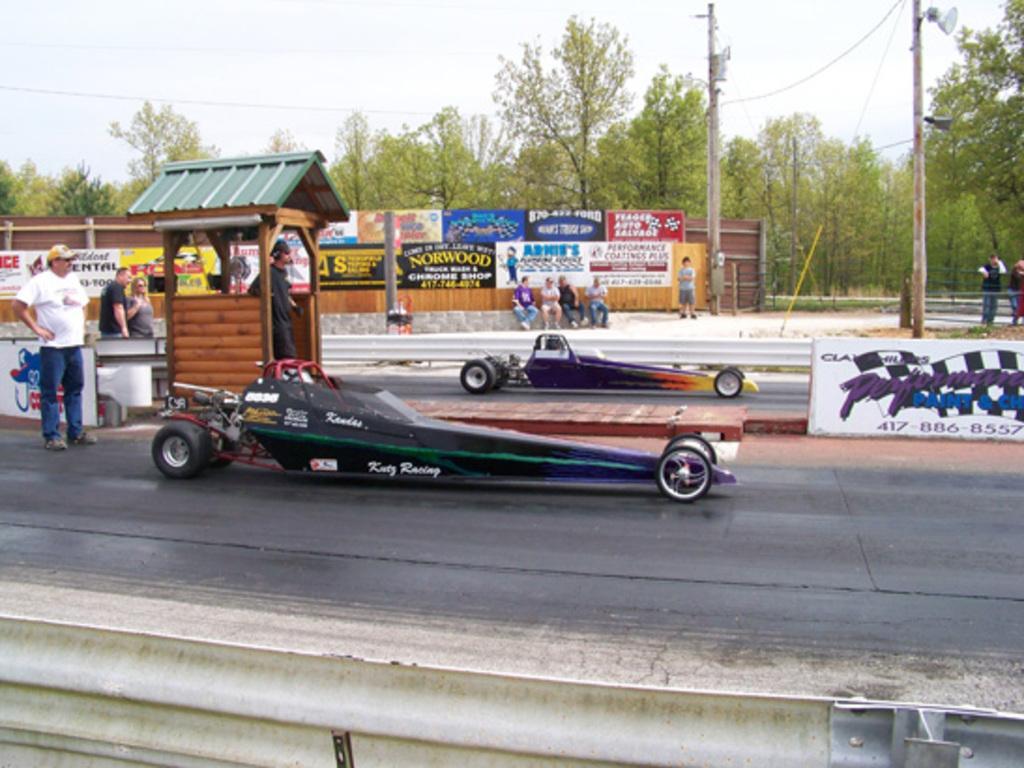How would you summarize this image in a sentence or two? In this image we can see a group of people. One man is standing inside a shed. In the center of the image we can see some vehicles parked on the ground, some people are sitting on the surface. In the foreground of the image we can see traffic barrier. In the background, we can see some banners with text, a group of trees and some poles. At the top of the image we can see the sky. 